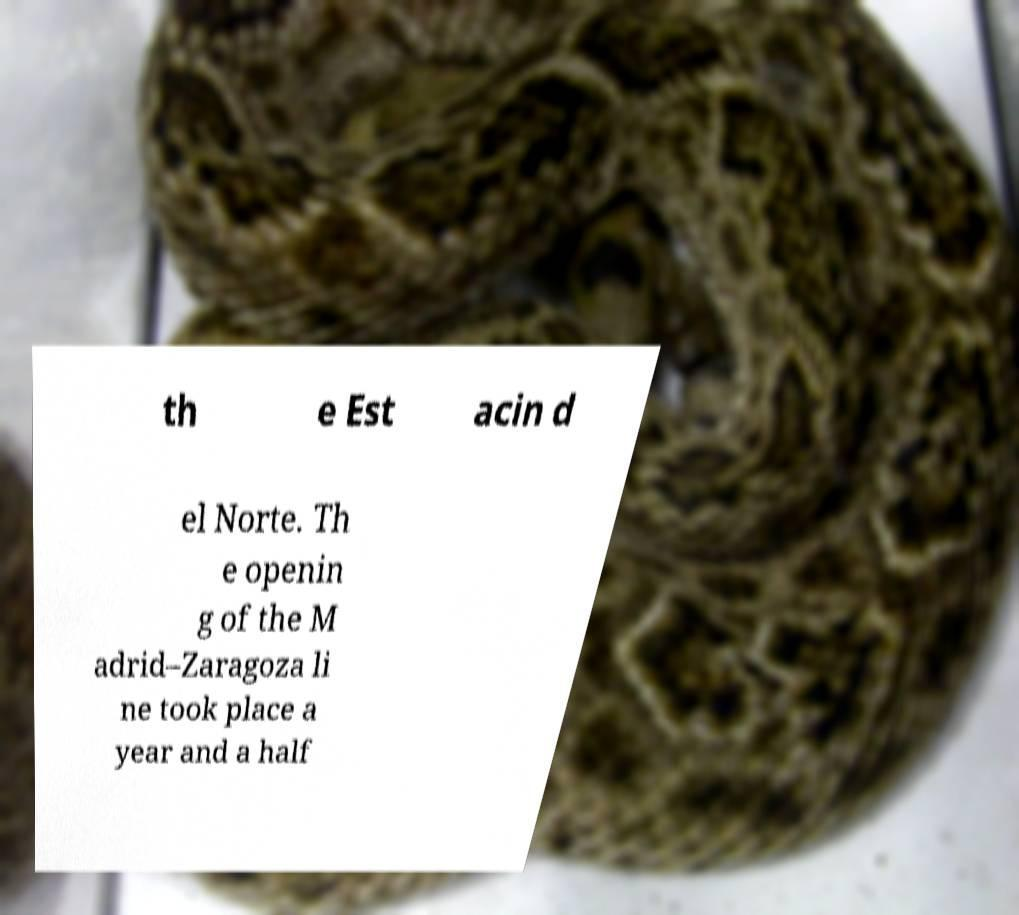For documentation purposes, I need the text within this image transcribed. Could you provide that? th e Est acin d el Norte. Th e openin g of the M adrid–Zaragoza li ne took place a year and a half 